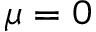Convert formula to latex. <formula><loc_0><loc_0><loc_500><loc_500>\mu = 0</formula> 